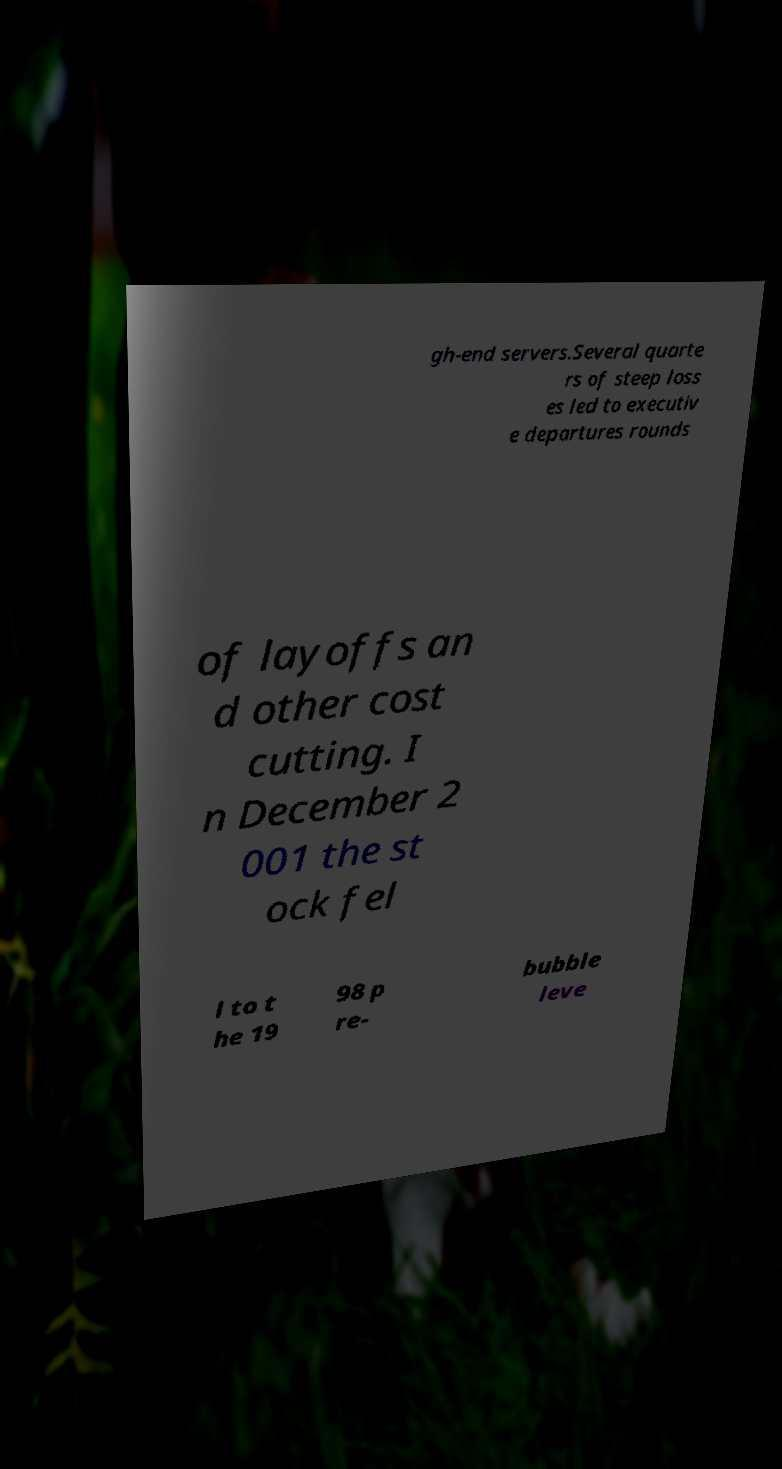Please read and relay the text visible in this image. What does it say? gh-end servers.Several quarte rs of steep loss es led to executiv e departures rounds of layoffs an d other cost cutting. I n December 2 001 the st ock fel l to t he 19 98 p re- bubble leve 